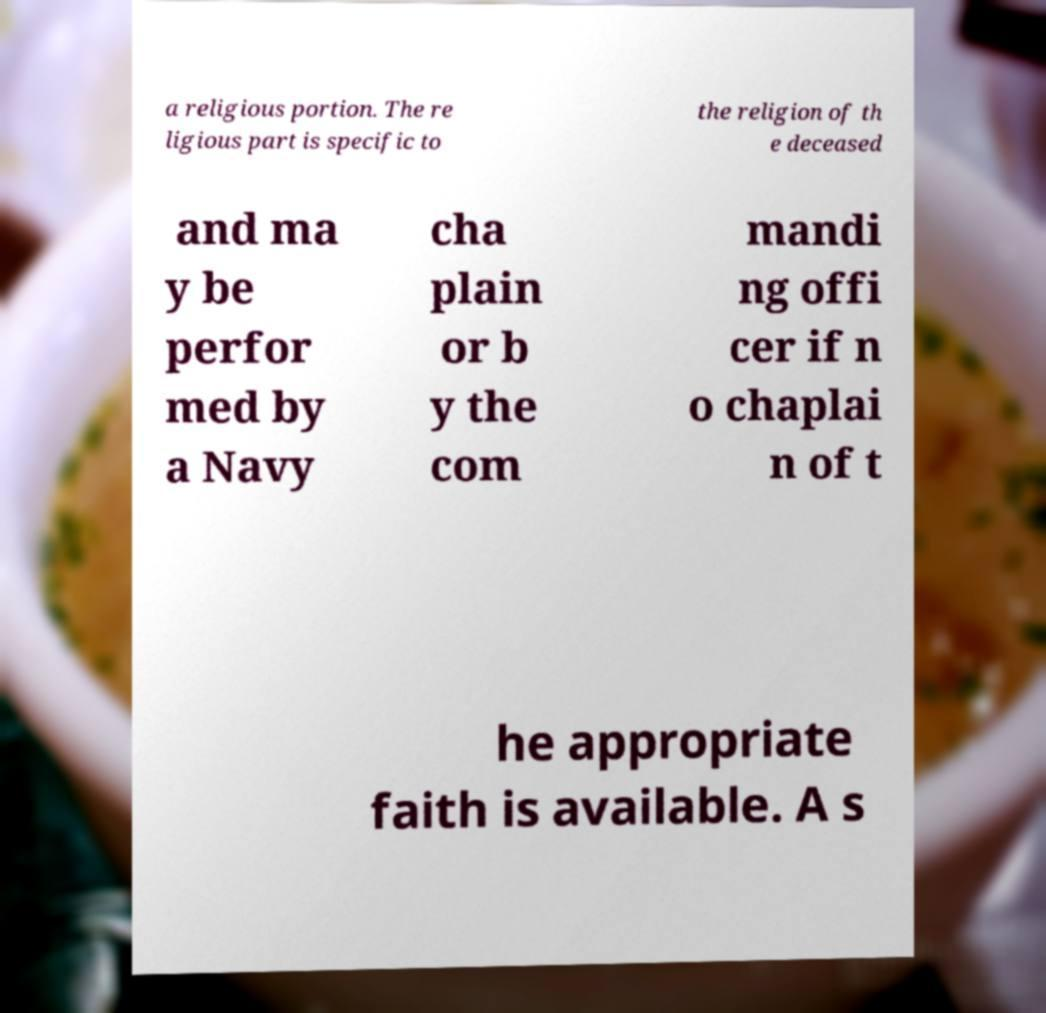Please identify and transcribe the text found in this image. a religious portion. The re ligious part is specific to the religion of th e deceased and ma y be perfor med by a Navy cha plain or b y the com mandi ng offi cer if n o chaplai n of t he appropriate faith is available. A s 